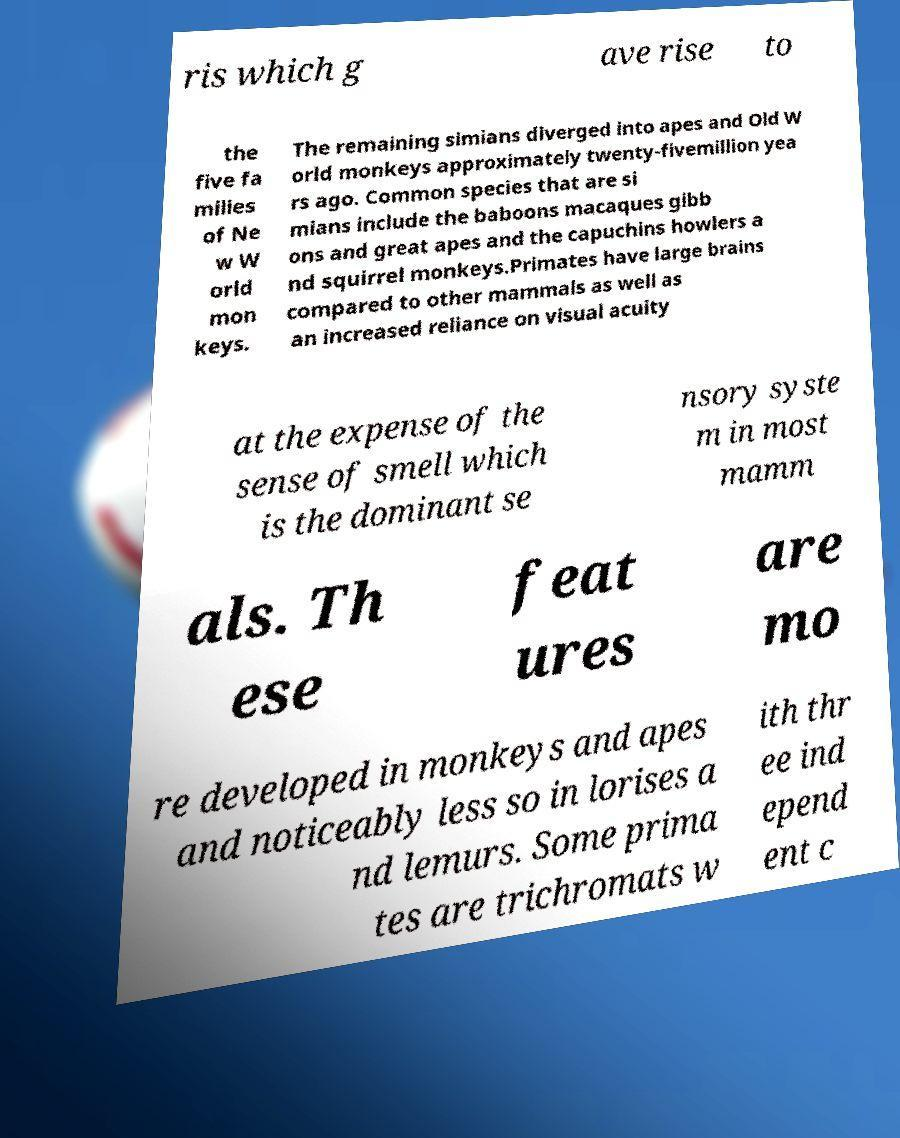Could you assist in decoding the text presented in this image and type it out clearly? ris which g ave rise to the five fa milies of Ne w W orld mon keys. The remaining simians diverged into apes and Old W orld monkeys approximately twenty-fivemillion yea rs ago. Common species that are si mians include the baboons macaques gibb ons and great apes and the capuchins howlers a nd squirrel monkeys.Primates have large brains compared to other mammals as well as an increased reliance on visual acuity at the expense of the sense of smell which is the dominant se nsory syste m in most mamm als. Th ese feat ures are mo re developed in monkeys and apes and noticeably less so in lorises a nd lemurs. Some prima tes are trichromats w ith thr ee ind epend ent c 